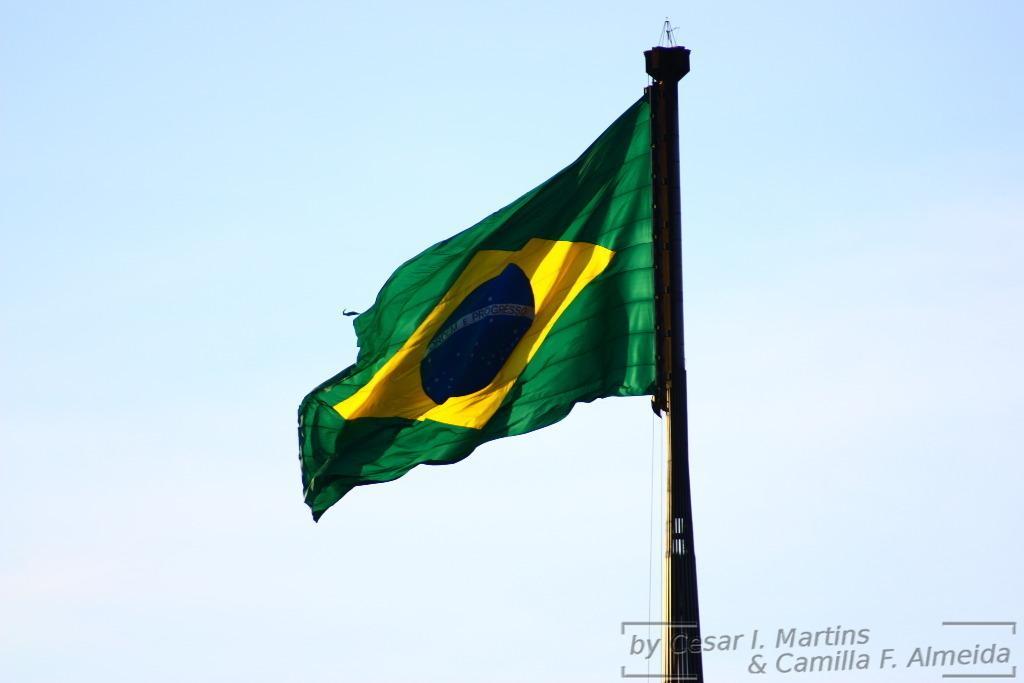Please provide a concise description of this image. In this image, we can see a green flag, in the background, we can see the sky. 